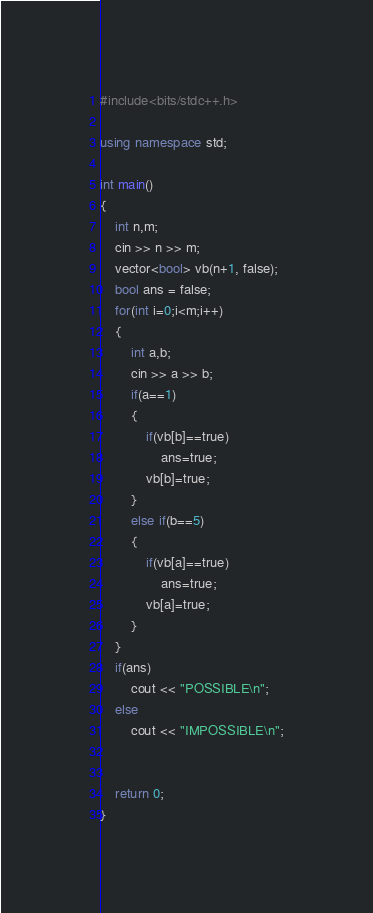<code> <loc_0><loc_0><loc_500><loc_500><_C++_>#include<bits/stdc++.h>

using namespace std;

int main()
{
    int n,m;
    cin >> n >> m;
    vector<bool> vb(n+1, false);
    bool ans = false;
    for(int i=0;i<m;i++)
    {
        int a,b;
        cin >> a >> b;
        if(a==1)
        {
            if(vb[b]==true)
                ans=true;
            vb[b]=true;
        }
        else if(b==5)
        {
            if(vb[a]==true)
                ans=true;
            vb[a]=true;
        }
    }
    if(ans)
        cout << "POSSIBLE\n";
    else
        cout << "IMPOSSIBLE\n";


    return 0;
}

</code> 